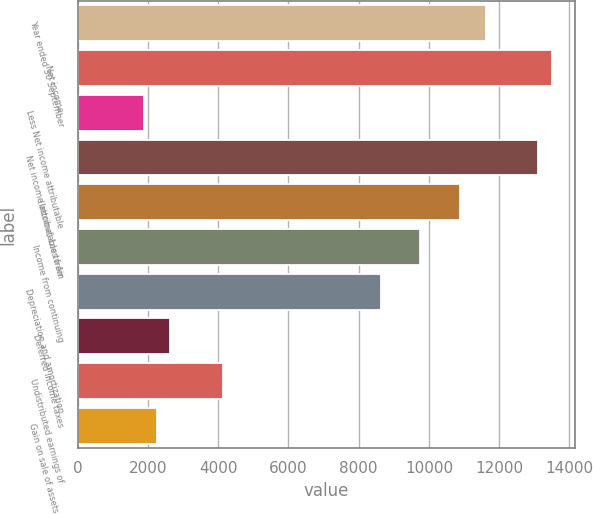Convert chart. <chart><loc_0><loc_0><loc_500><loc_500><bar_chart><fcel>Year ended 30 September<fcel>Net income<fcel>Less Net income attributable<fcel>Net income attributable to Air<fcel>(Income) Loss from<fcel>Income from continuing<fcel>Depreciation and amortization<fcel>Deferred income taxes<fcel>Undistributed earnings of<fcel>Gain on sale of assets and<nl><fcel>11622<fcel>13496.2<fcel>1876.45<fcel>13121.4<fcel>10872.4<fcel>9747.88<fcel>8623.39<fcel>2626.11<fcel>4125.43<fcel>2251.28<nl></chart> 